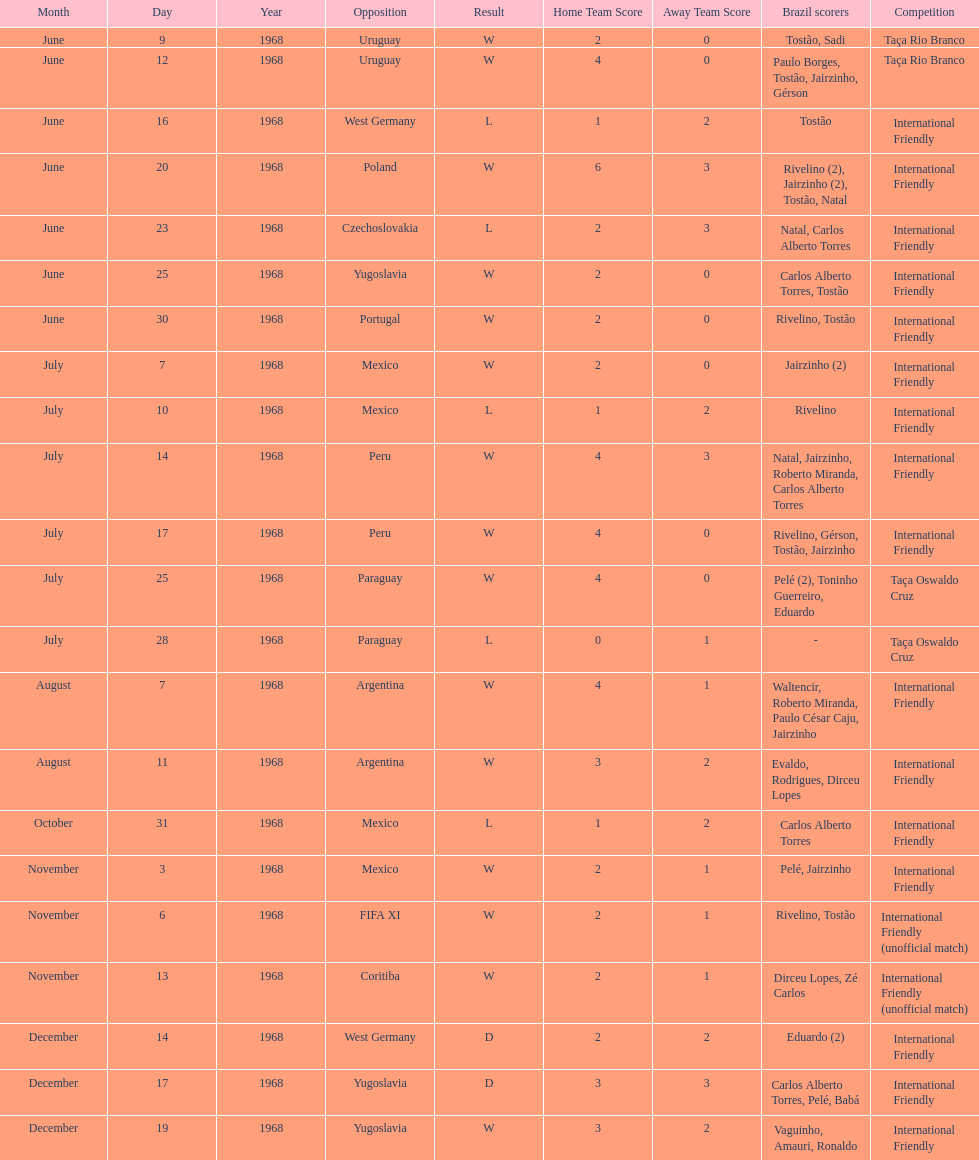What's the total number of ties? 2. 